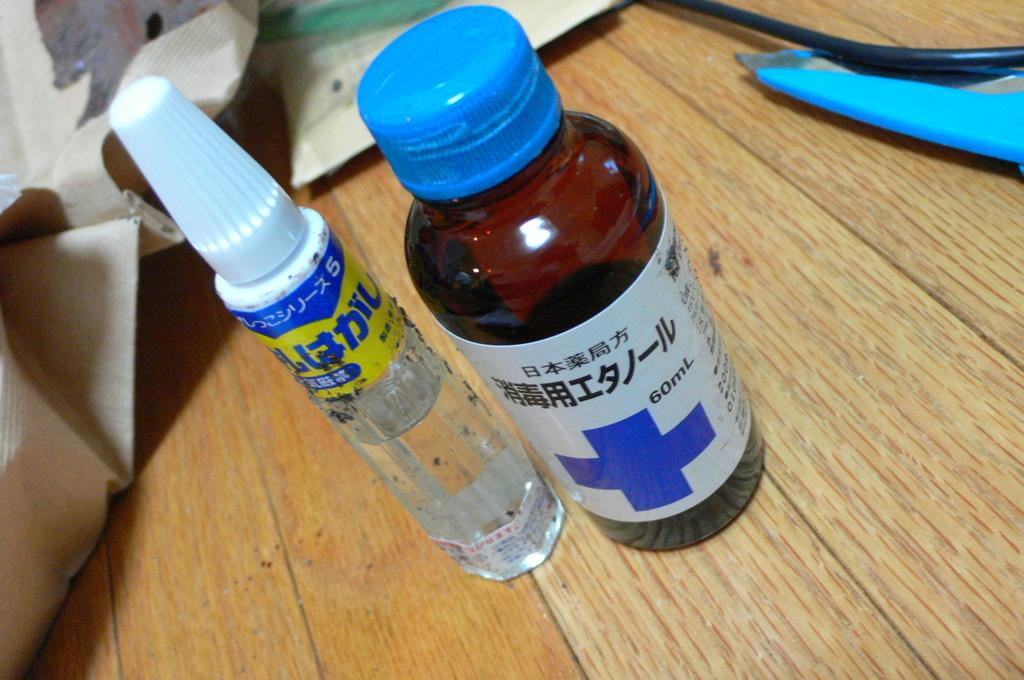Provide a one-sentence caption for the provided image. Two bottles, one clear and one brown, with labels written in Japanese. 